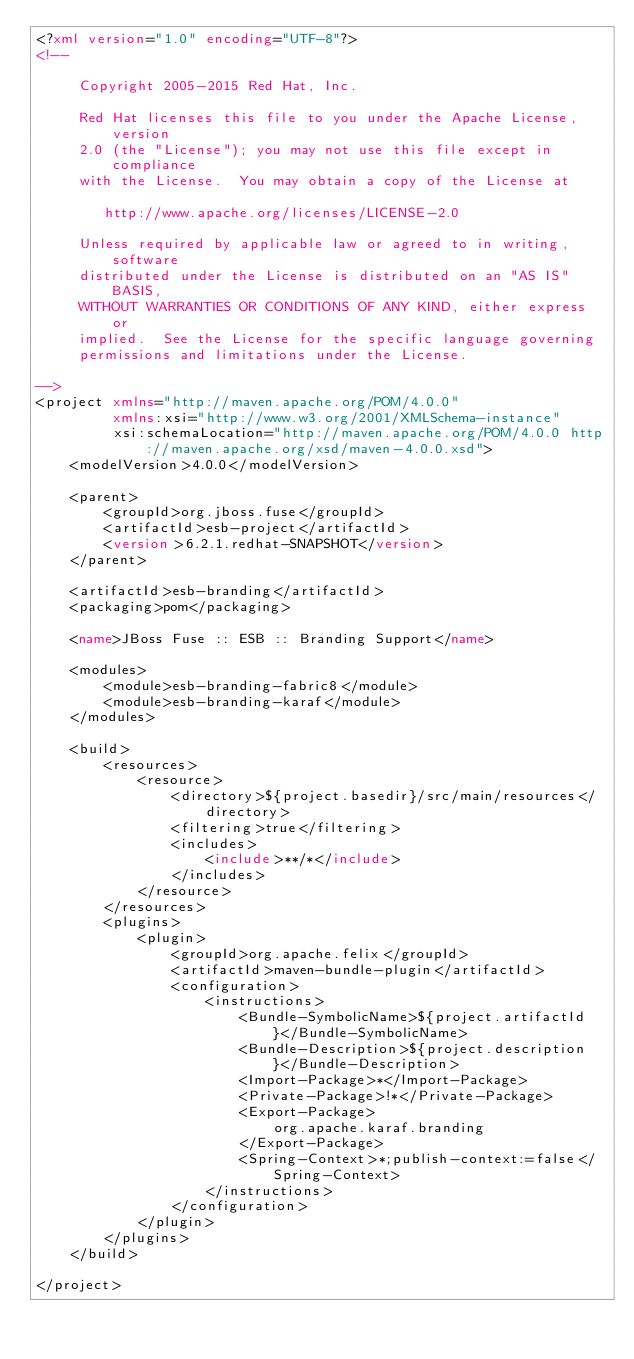<code> <loc_0><loc_0><loc_500><loc_500><_XML_><?xml version="1.0" encoding="UTF-8"?>
<!--

     Copyright 2005-2015 Red Hat, Inc.

     Red Hat licenses this file to you under the Apache License, version
     2.0 (the "License"); you may not use this file except in compliance
     with the License.  You may obtain a copy of the License at

        http://www.apache.org/licenses/LICENSE-2.0

     Unless required by applicable law or agreed to in writing, software
     distributed under the License is distributed on an "AS IS" BASIS,
     WITHOUT WARRANTIES OR CONDITIONS OF ANY KIND, either express or
     implied.  See the License for the specific language governing
     permissions and limitations under the License.

-->
<project xmlns="http://maven.apache.org/POM/4.0.0"
         xmlns:xsi="http://www.w3.org/2001/XMLSchema-instance"
         xsi:schemaLocation="http://maven.apache.org/POM/4.0.0 http://maven.apache.org/xsd/maven-4.0.0.xsd">
    <modelVersion>4.0.0</modelVersion>
         
    <parent>
        <groupId>org.jboss.fuse</groupId>
        <artifactId>esb-project</artifactId>
        <version>6.2.1.redhat-SNAPSHOT</version>
    </parent>

    <artifactId>esb-branding</artifactId>
    <packaging>pom</packaging>
    
    <name>JBoss Fuse :: ESB :: Branding Support</name>

    <modules>
        <module>esb-branding-fabric8</module>
        <module>esb-branding-karaf</module>
    </modules>

    <build>
        <resources>
            <resource>
                <directory>${project.basedir}/src/main/resources</directory>
                <filtering>true</filtering>
                <includes>
                    <include>**/*</include>
                </includes>
            </resource>
        </resources>
        <plugins>
            <plugin>
                <groupId>org.apache.felix</groupId>
                <artifactId>maven-bundle-plugin</artifactId>
                <configuration>
                    <instructions>
                        <Bundle-SymbolicName>${project.artifactId}</Bundle-SymbolicName>
                        <Bundle-Description>${project.description}</Bundle-Description>
                        <Import-Package>*</Import-Package>
                        <Private-Package>!*</Private-Package>
                        <Export-Package>
                            org.apache.karaf.branding        
                        </Export-Package>
                        <Spring-Context>*;publish-context:=false</Spring-Context>
                    </instructions>
                </configuration>
            </plugin>
        </plugins>
    </build>

</project>
</code> 